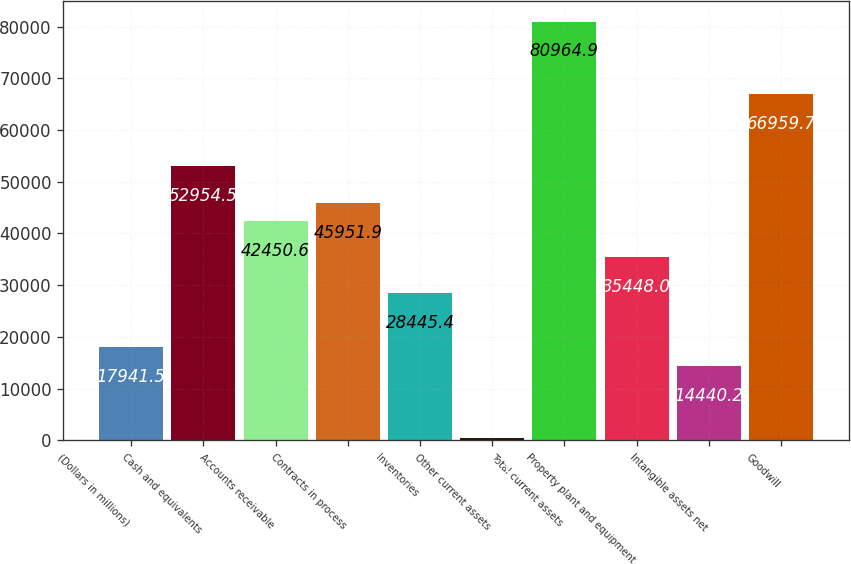<chart> <loc_0><loc_0><loc_500><loc_500><bar_chart><fcel>(Dollars in millions)<fcel>Cash and equivalents<fcel>Accounts receivable<fcel>Contracts in process<fcel>Inventories<fcel>Other current assets<fcel>Total current assets<fcel>Property plant and equipment<fcel>Intangible assets net<fcel>Goodwill<nl><fcel>17941.5<fcel>52954.5<fcel>42450.6<fcel>45951.9<fcel>28445.4<fcel>435<fcel>80964.9<fcel>35448<fcel>14440.2<fcel>66959.7<nl></chart> 